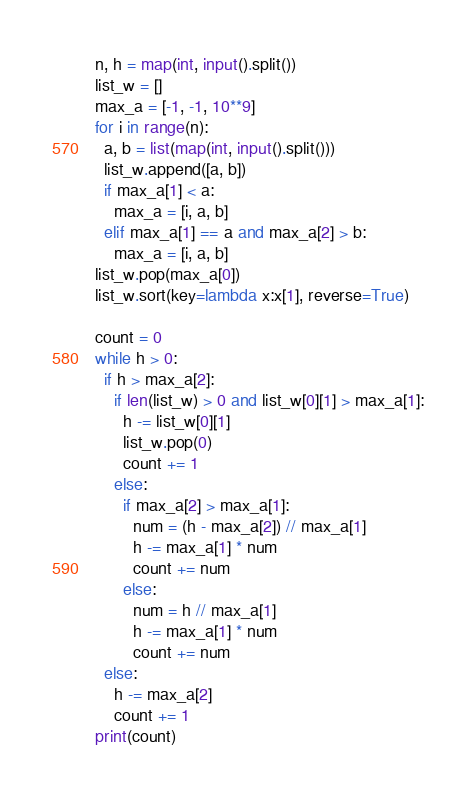Convert code to text. <code><loc_0><loc_0><loc_500><loc_500><_Python_>n, h = map(int, input().split())
list_w = []
max_a = [-1, -1, 10**9]
for i in range(n):
  a, b = list(map(int, input().split()))
  list_w.append([a, b])
  if max_a[1] < a:
    max_a = [i, a, b]
  elif max_a[1] == a and max_a[2] > b:
    max_a = [i, a, b]  
list_w.pop(max_a[0])
list_w.sort(key=lambda x:x[1], reverse=True)

count = 0
while h > 0:
  if h > max_a[2]:
    if len(list_w) > 0 and list_w[0][1] > max_a[1]:
      h -= list_w[0][1]
      list_w.pop(0)
      count += 1
    else:
      if max_a[2] > max_a[1]:
        num = (h - max_a[2]) // max_a[1]
        h -= max_a[1] * num
        count += num
      else:
        num = h // max_a[1]
        h -= max_a[1] * num
        count += num
  else:
    h -= max_a[2]
    count += 1
print(count)</code> 